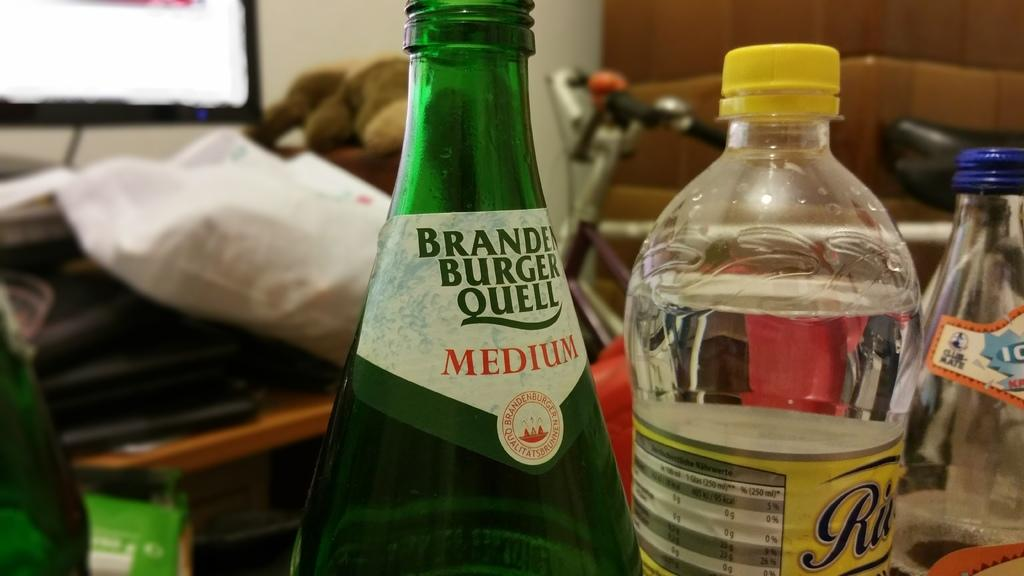<image>
Offer a succinct explanation of the picture presented. A bottle with the word "MEDIUM" on the label sits next to another bottle. 